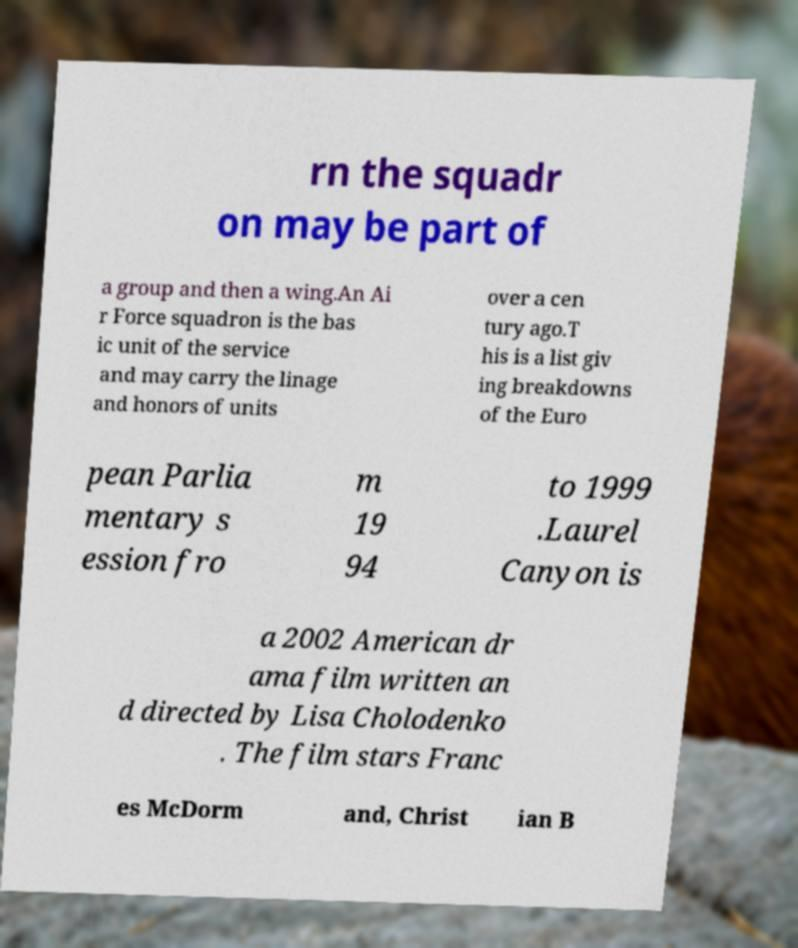Please identify and transcribe the text found in this image. rn the squadr on may be part of a group and then a wing.An Ai r Force squadron is the bas ic unit of the service and may carry the linage and honors of units over a cen tury ago.T his is a list giv ing breakdowns of the Euro pean Parlia mentary s ession fro m 19 94 to 1999 .Laurel Canyon is a 2002 American dr ama film written an d directed by Lisa Cholodenko . The film stars Franc es McDorm and, Christ ian B 